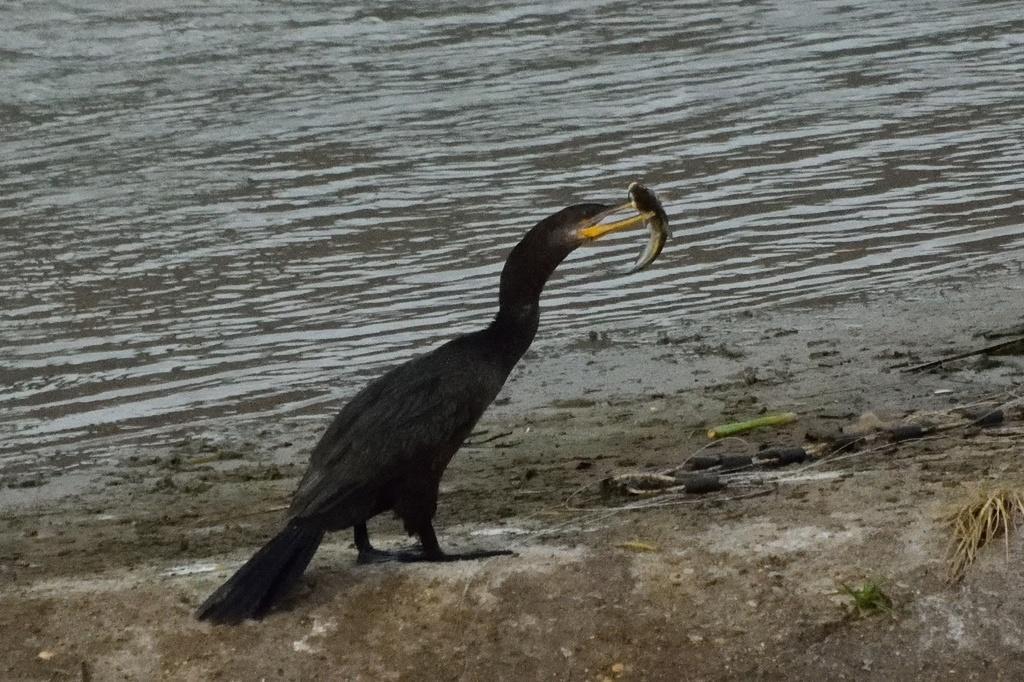How would you summarize this image in a sentence or two? In the center of the image we can see a bird and holding a fish through beak. In the background of the image we can see the water. At the bottom of the image we can see the ground. 